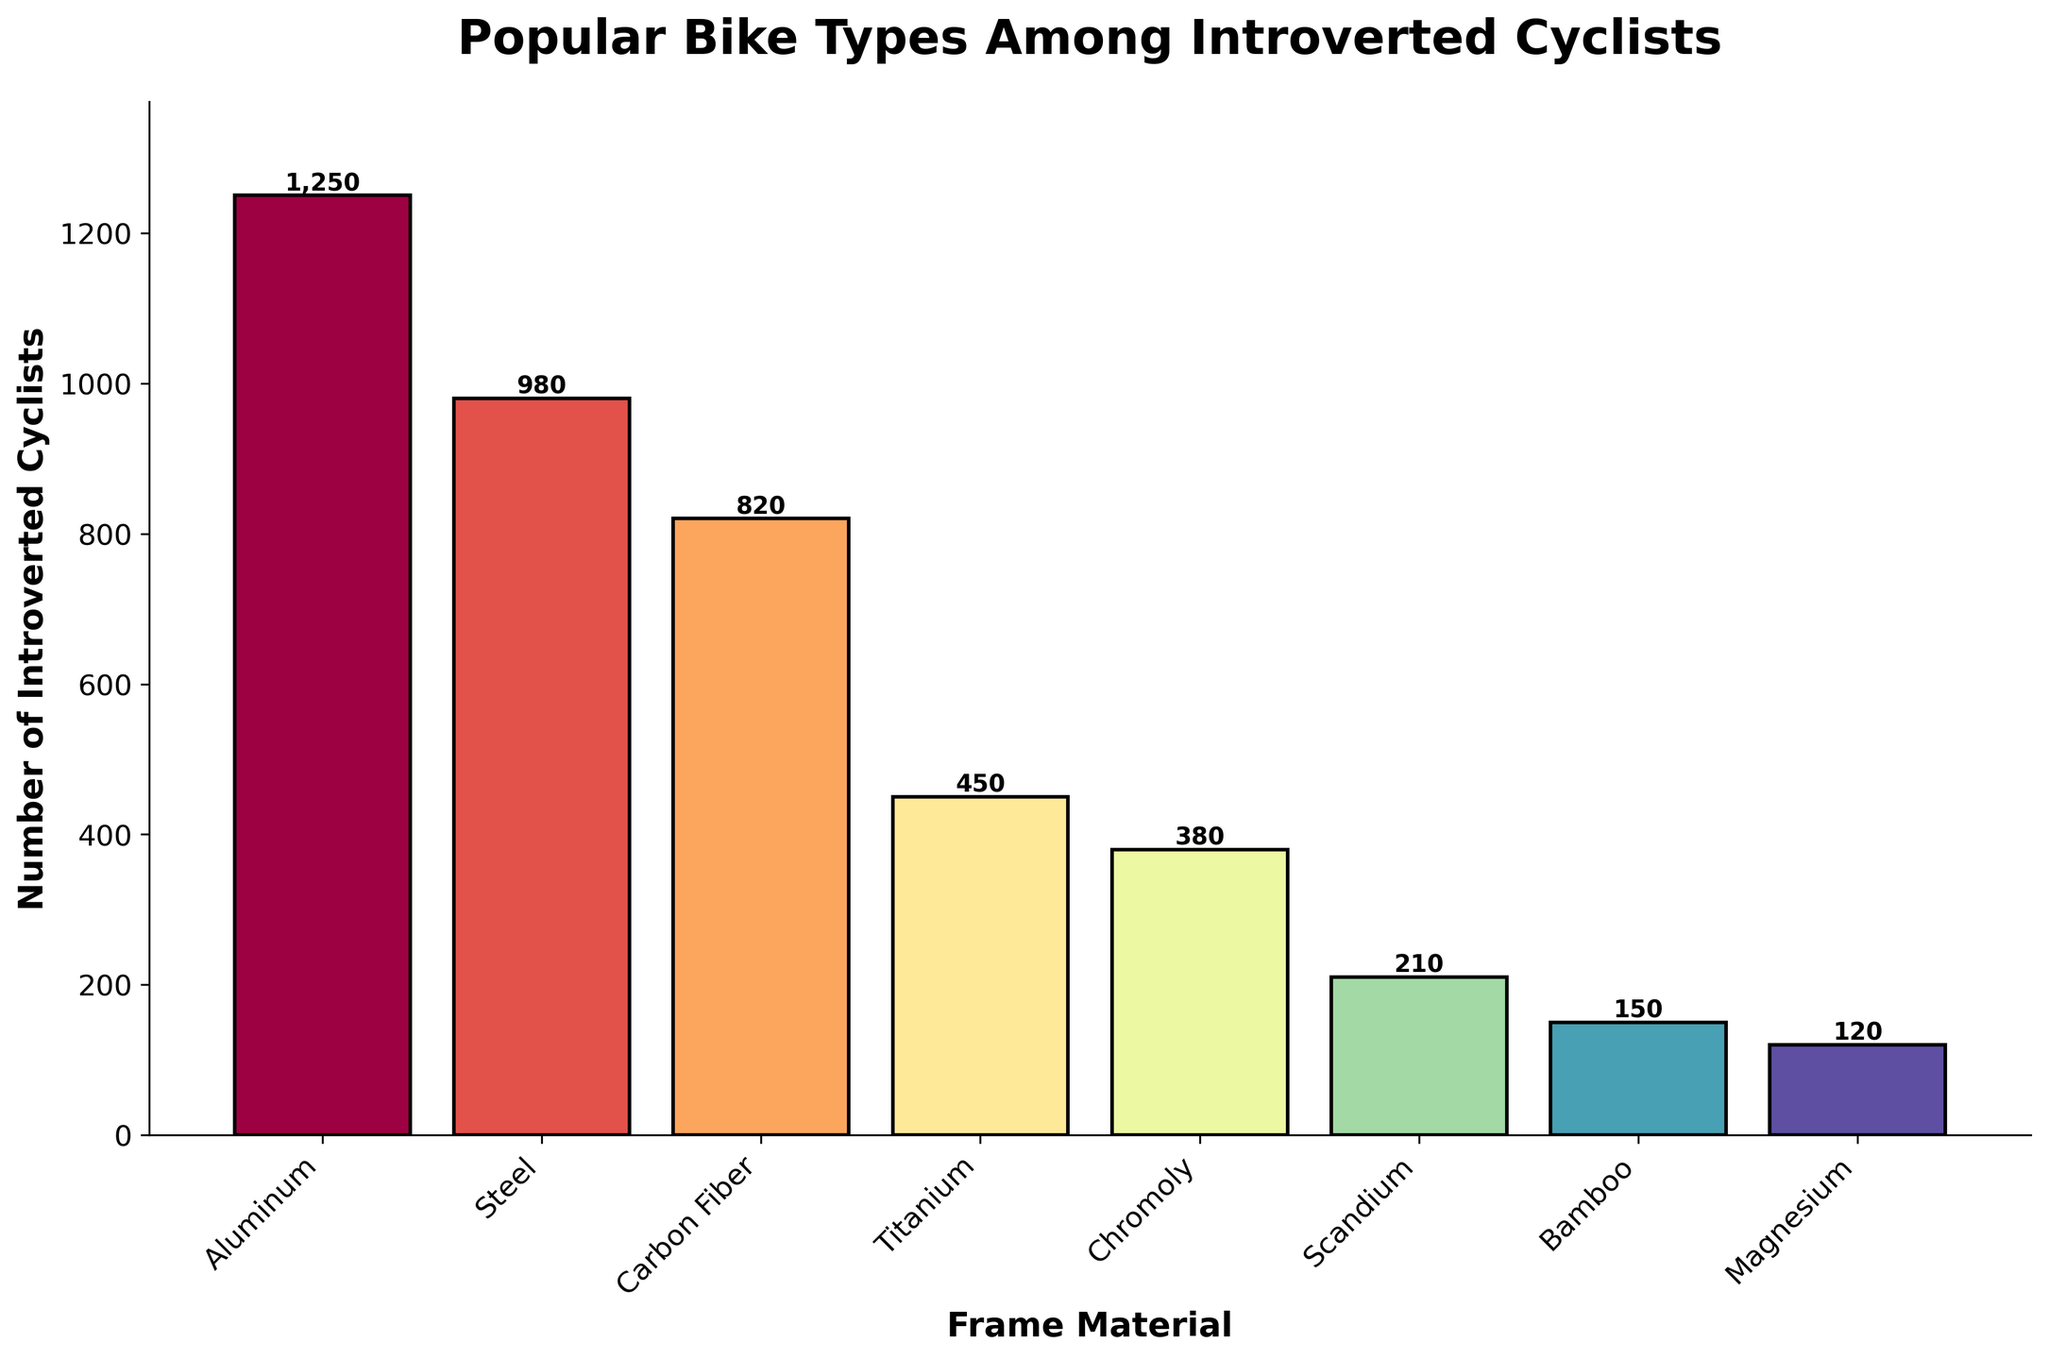What is the most popular frame material among introverted cyclists? The figure shows the number of introverted cyclists using different frame materials, with the highest bar representing the most popular material. By identifying the tallest bar, we can see that Aluminum is the most popular frame material.
Answer: Aluminum Which frame material is more popular, Steel or Carbon Fiber? The bars representing Steel and Carbon Fiber can be compared visually. The bar for Steel is higher than the bar for Carbon Fiber, indicating that Steel is more popular.
Answer: Steel How many more introverted cyclists use Aluminum frames compared to Titanium frames? To find the difference, look at the heights of the Aluminum and Titanium bars. The Aluminum bar represents 1250 cyclists, and the Titanium bar represents 450 cyclists. Subtract the number for Titanium from Aluminum: 1250 - 450 = 800.
Answer: 800 What is the combined number of introverted cyclists using Chromoly and Magnesium frames? To find the sum, add the number of cyclists for Chromoly and Magnesium. The bars show 380 for Chromoly and 120 for Magnesium: 380 + 120 = 500.
Answer: 500 What frame material has the lowest number of introverted cyclists? The figure's shortest bar represents the frame material with the lowest count. The shortest bar corresponds to Magnesium.
Answer: Magnesium What is the difference in the number of introverted cyclists between the most popular and least popular frame materials? Identify the counts for the most popular (Aluminum, 1250) and the least popular (Magnesium, 120). Subtract the least popular from the most popular: 1250 - 120 = 1130.
Answer: 1130 What percentage of introverted cyclists use Steel frames compared to the total number of cyclists shown? Calculate the total number of cyclists by summing all the counts: 1250 + 980 + 820 + 450 + 380 + 210 + 150 + 120 = 4360. Then divide the number of Steel users (980) by the total and multiply by 100: (980 / 4360) * 100 ≈ 22.48%.
Answer: 22.48% How does the popularity of Bamboo frames compare to Scandium frames in terms of cyclist count? Compare the heights of the Bamboo and Scandium bars. The Bamboo bar represents 150 cyclists, and the Scandium bar represents 210 cyclists. Bamboo is less popular than Scandium.
Answer: Less popular Is the height of the Carbon Fiber bar more than or less than half the height of the Aluminum bar? Compare half the height of the Aluminum bar to the full height of the Carbon Fiber bar. Half of the Aluminum count is 1250 / 2 = 625. The Carbon Fiber bar represents 820 cyclists, which is more than 625.
Answer: More What is the approximate ratio of introverted cyclists using Titanium frames to those using Chromoly frames? Identify the counts for Titanium (450) and Chromoly (380). The approximate ratio is 450 to 380, which simplifies to approximately 9:8.
Answer: 9:8 